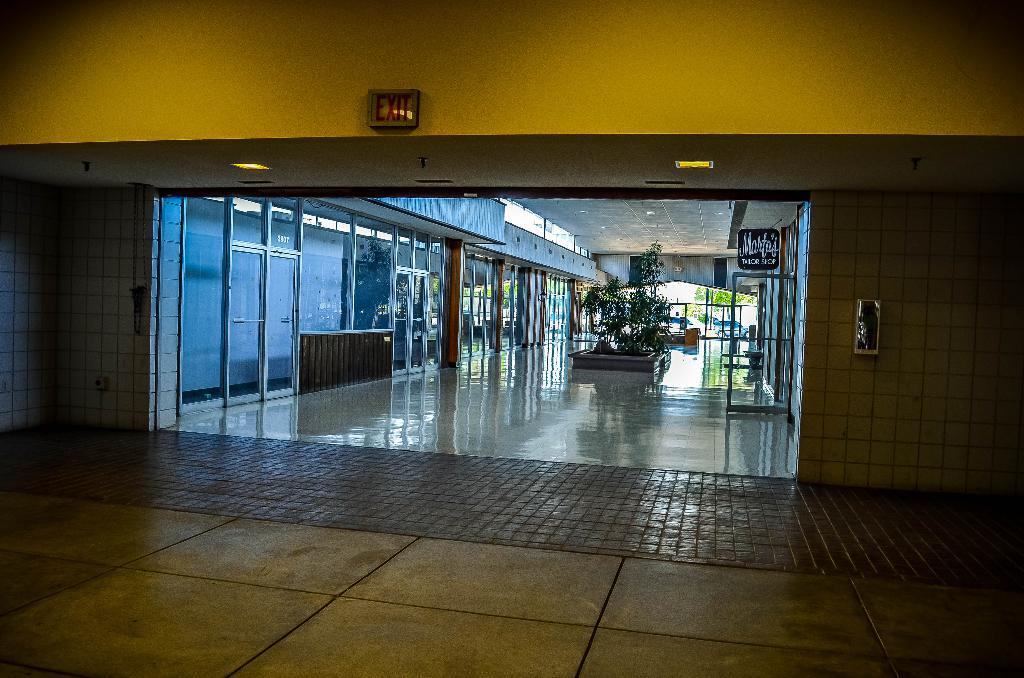What type of location is depicted in the image? The image shows an inside view of a building. What feature can be seen on the doors in the image? The doors in the image are made of glass. What type of vegetation is present in the image? There are plants in the image. What objects are used for displaying information or advertisements in the image? There are boards in the image. What mode of transportation is visible in the image? There is a vehicle in the image. Are there any people wearing masks at the party in the image? There is no party or people wearing masks present in the image. How many legs can be seen on the legless creature in the image? There is no legless creature present in the image. 